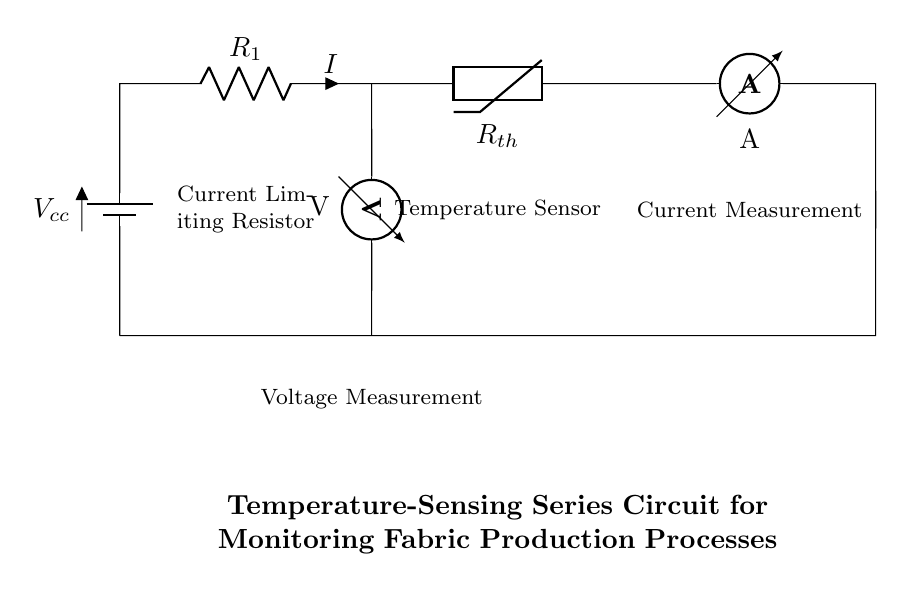What is the total voltage supplied in the circuit? The total voltage is defined by the battery, marked as Vcc. Since no specific voltage value is given in the question context, we can refer to it simply as Vcc.
Answer: Vcc What component is used as a temperature sensor in this circuit? The temperature sensor is indicated as a thermistor (labelled Rth) in the circuit. A thermistor changes its resistance with temperature, making it ideal for temperature sensing.
Answer: Thermistor What is the function of the resistor labeled R1? The resistor labeled R1 is a current-limiting resistor. It regulates the current flowing through the circuit, ensuring the thermistor and other components operate within safe limits.
Answer: Current Limiting Resistor How is the current measured in this circuit? The current is measured using the device labeled A, which stands for an ammeter. The ammeter is connected in series with the rest of the circuit to accurately measure the current flowing through all components.
Answer: Ammeter What does the voltmeter measure in this circuit? The voltmeter, which is connected parallel to R1, measures the voltage across the current-limiting resistor. This measurement can help in determining the current flowing through the circuit using Ohm's law, as voltage across a known resistance is proportional to the current.
Answer: Voltage across the resistor What is the purpose of having both a voltmeter and an ammeter in this circuit? The circuit incorporates both instruments to monitor real-time performance. The voltmeter measures voltage to help calculate current (using Ohm's law), while the ammeter directly measures the current in the circuit. This dual monitoring allows for better control and understanding of the temperature and overall circuit performance.
Answer: Real-time performance monitoring 